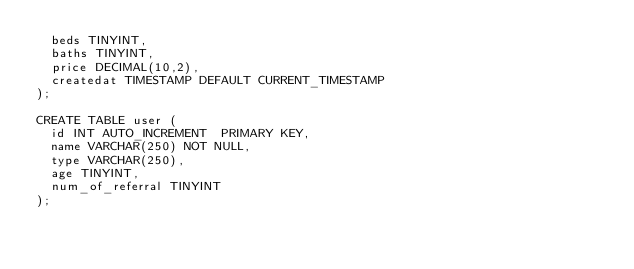Convert code to text. <code><loc_0><loc_0><loc_500><loc_500><_SQL_>  beds TINYINT,
  baths TINYINT,
  price DECIMAL(10,2),
  createdat TIMESTAMP DEFAULT CURRENT_TIMESTAMP
);

CREATE TABLE user (
  id INT AUTO_INCREMENT  PRIMARY KEY,
  name VARCHAR(250) NOT NULL,
  type VARCHAR(250),
  age TINYINT,
  num_of_referral TINYINT
);</code> 